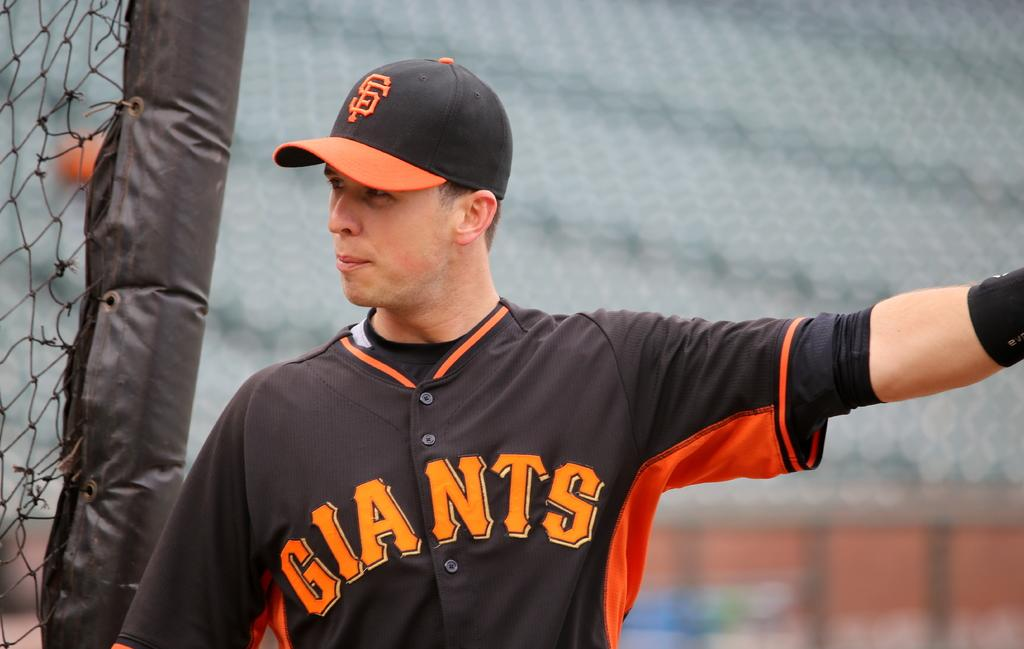Provide a one-sentence caption for the provided image. Giants is displayed on this player's baseball uniform. 